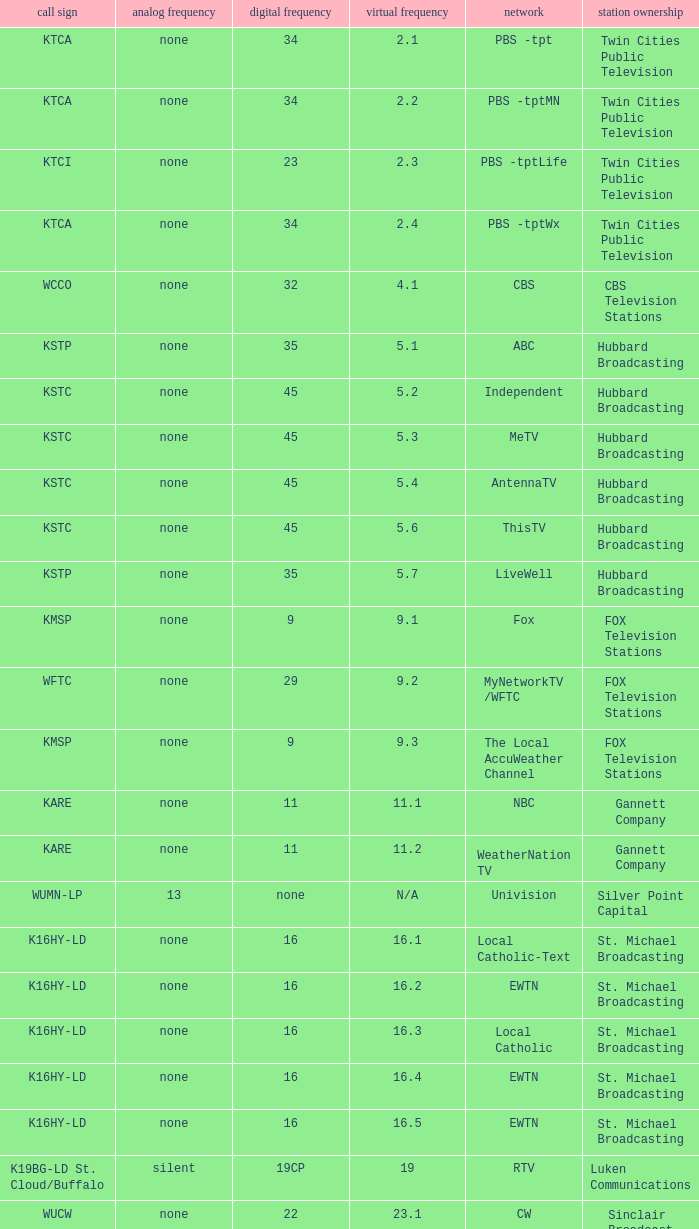Virtual channel of 16.5 has what call sign? K16HY-LD. 